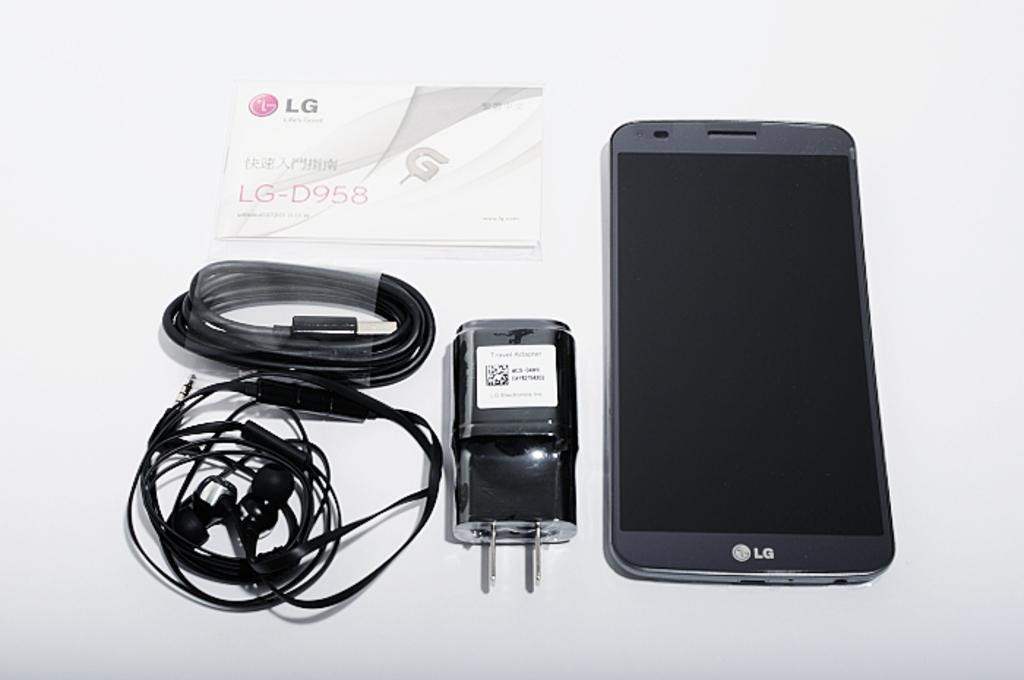<image>
Describe the image concisely. An LG D958 phone shown next to its charging cord. 